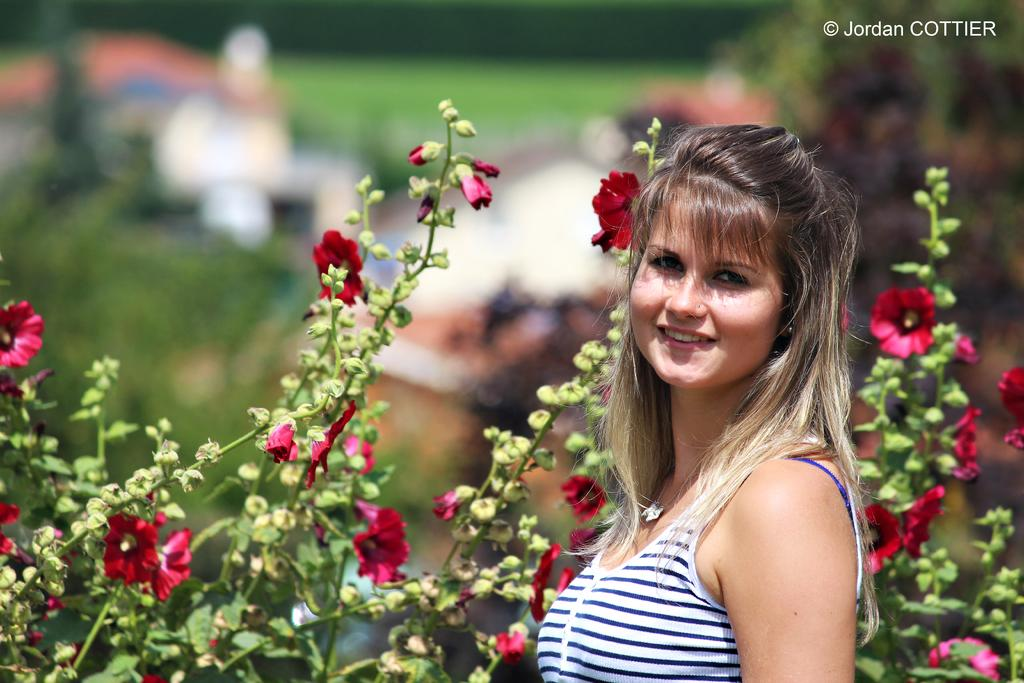What is the main subject in the foreground of the image? There is a woman in the foreground of the image. What type of plants are visible in the foreground of the image? There are flowering plants in the foreground of the image. Can you describe the background of the image? There is a person, grass, and trees in the background of the image. What type of location might the image have been taken in? The image may have been taken in a park, given the presence of grass, trees, and flowering plants. What class is the woman attending in the image? There is no indication of a class or any educational setting in the image. 